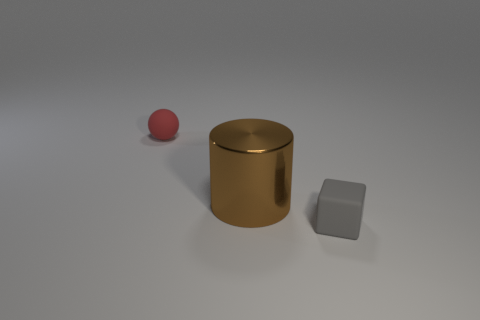Add 2 tiny metal spheres. How many objects exist? 5 Subtract all blocks. How many objects are left? 2 Subtract all cubes. Subtract all tiny matte blocks. How many objects are left? 1 Add 3 rubber things. How many rubber things are left? 5 Add 1 large purple rubber spheres. How many large purple rubber spheres exist? 1 Subtract 0 gray spheres. How many objects are left? 3 